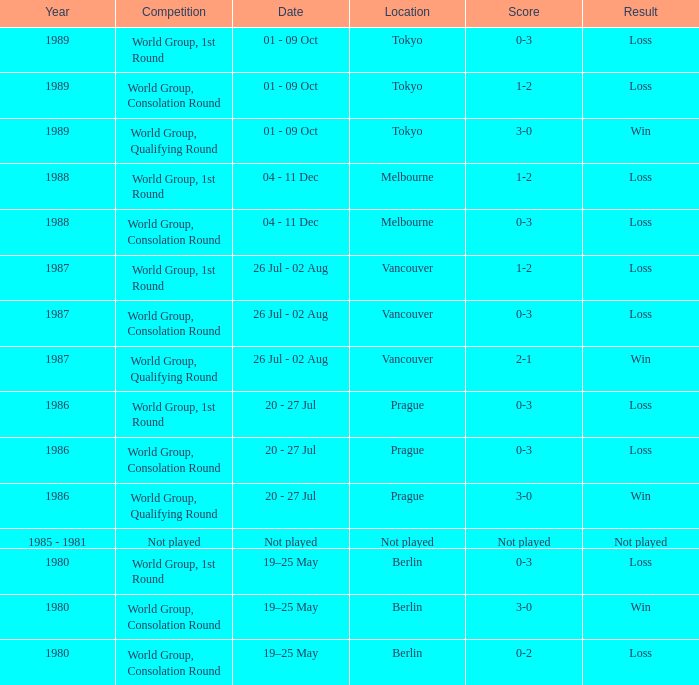What is the competition when the result is loss in berlin with a score of 0-3? World Group, 1st Round. 